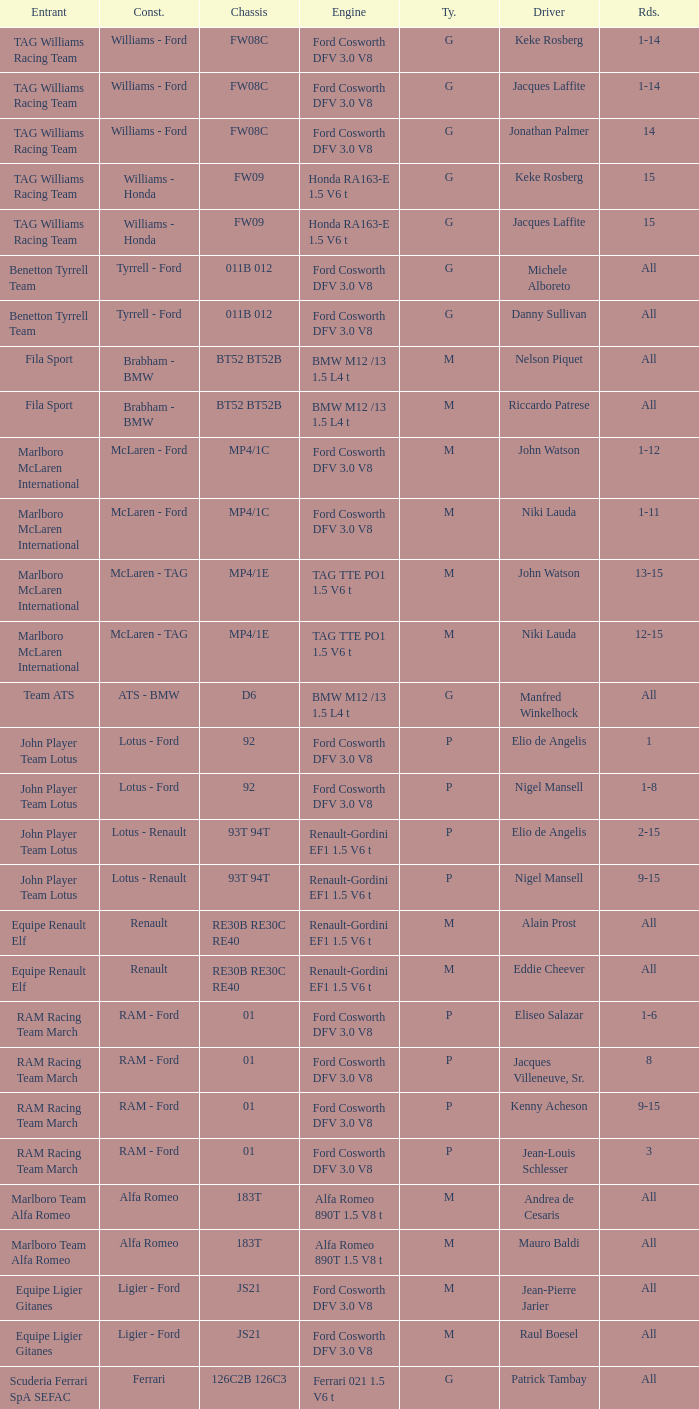Who is the constructor for driver Niki Lauda and a chassis of mp4/1c? McLaren - Ford. 